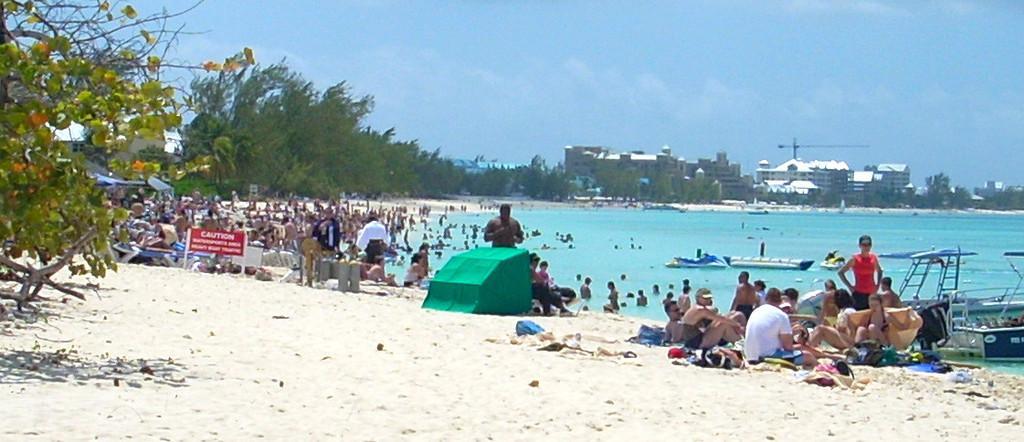In one or two sentences, can you explain what this image depicts? In this picture there are people on the right and left side of the image, there are boats on the water and there are people those who are swimming in the image and there are trees and buildings in the background area of the image and there is a caution board on the left side of the image. 